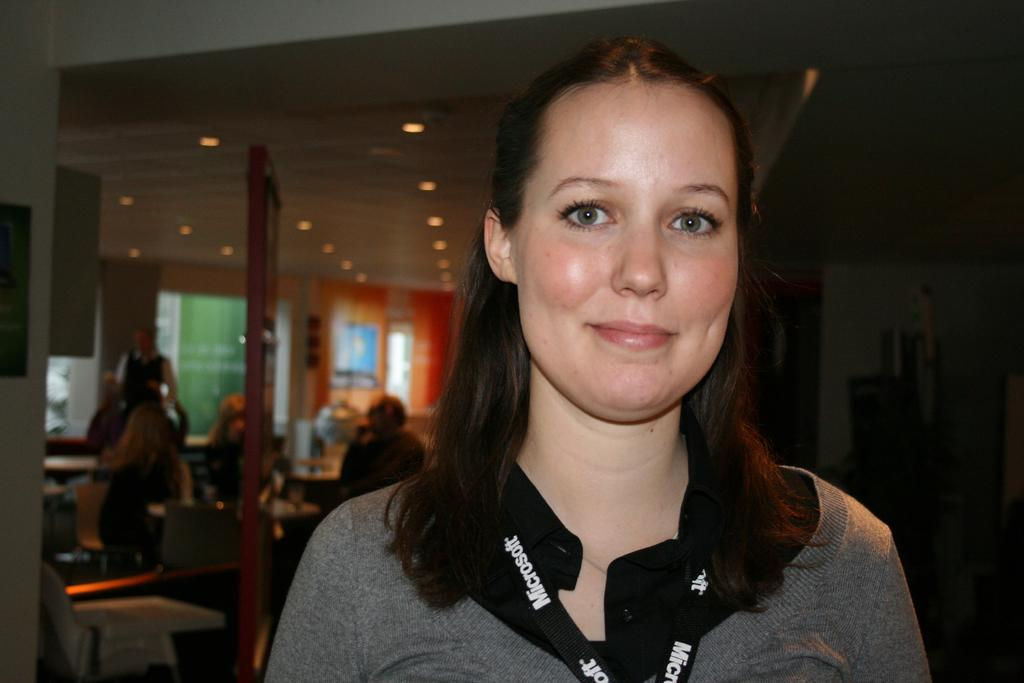<image>
Relay a brief, clear account of the picture shown. A smiling woman wears a black lanyard with the Microsoft name on it. 